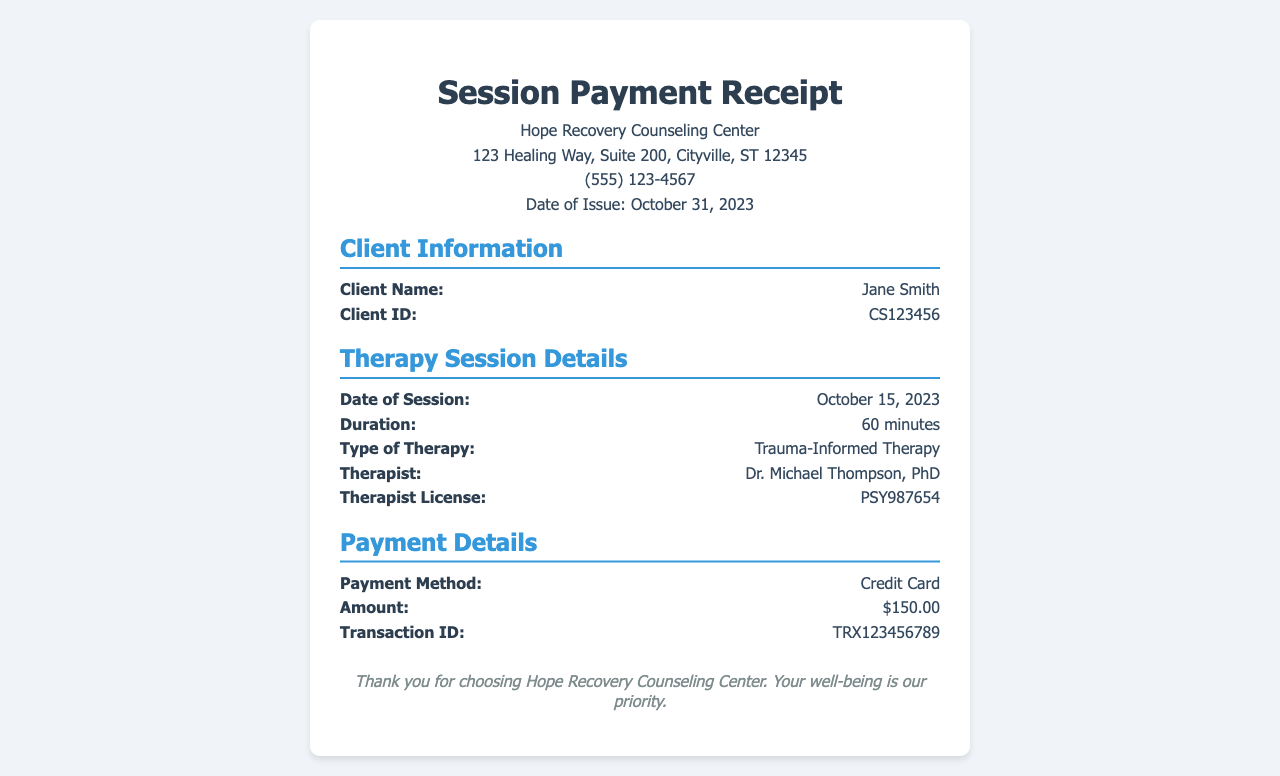What is the client's name? The document specifies the name of the client in the client information section.
Answer: Jane Smith What is the date of the session? The session date is noted in the therapy session details, indicating when the therapy took place.
Answer: October 15, 2023 What is the duration of the therapy session? The duration is mentioned in the therapy session details, reflecting how long the session lasted.
Answer: 60 minutes Who is the therapist? The therapist's name is provided in the therapy session details, indicating who provided the therapy.
Answer: Dr. Michael Thompson, PhD What was the payment method used? The payment details section of the document states how the client paid for the session.
Answer: Credit Card What is the transaction ID? The transaction ID is provided in the payment details, serving as a reference for the payment made.
Answer: TRX123456789 How much was the session charged? The document indicates the charge for the therapy session in the payment details section.
Answer: $150.00 What type of therapy was conducted? The therapy type is specified in the therapy session details, indicating the nature of the therapy provided.
Answer: Trauma-Informed Therapy 